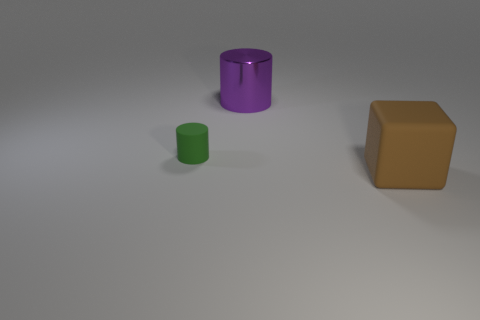Can you tell me the sizes of the objects relative to each other? Certainly! The image displays three objects of varying sizes. Starting with the smallest, we have a green cylinder, which you could think of as roughly the size of a standard cup. Next is the purple cylinder, noticeably larger, akin in size to a decorative vase. Finally, the brown cube resembles a small cardboard box. 